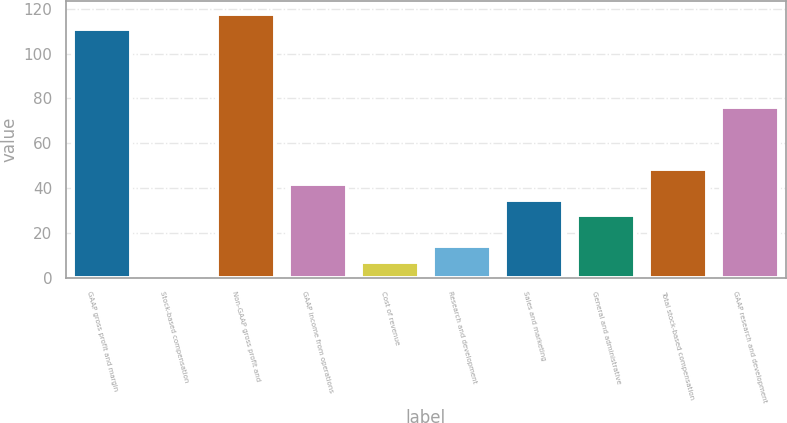<chart> <loc_0><loc_0><loc_500><loc_500><bar_chart><fcel>GAAP gross profit and margin<fcel>Stock-based compensation<fcel>Non-GAAP gross profit and<fcel>GAAP income from operations<fcel>Cost of revenue<fcel>Research and development<fcel>Sales and marketing<fcel>General and administrative<fcel>Total stock-based compensation<fcel>GAAP research and development<nl><fcel>110.76<fcel>0.2<fcel>117.67<fcel>41.66<fcel>7.11<fcel>14.02<fcel>34.75<fcel>27.84<fcel>48.57<fcel>76.21<nl></chart> 